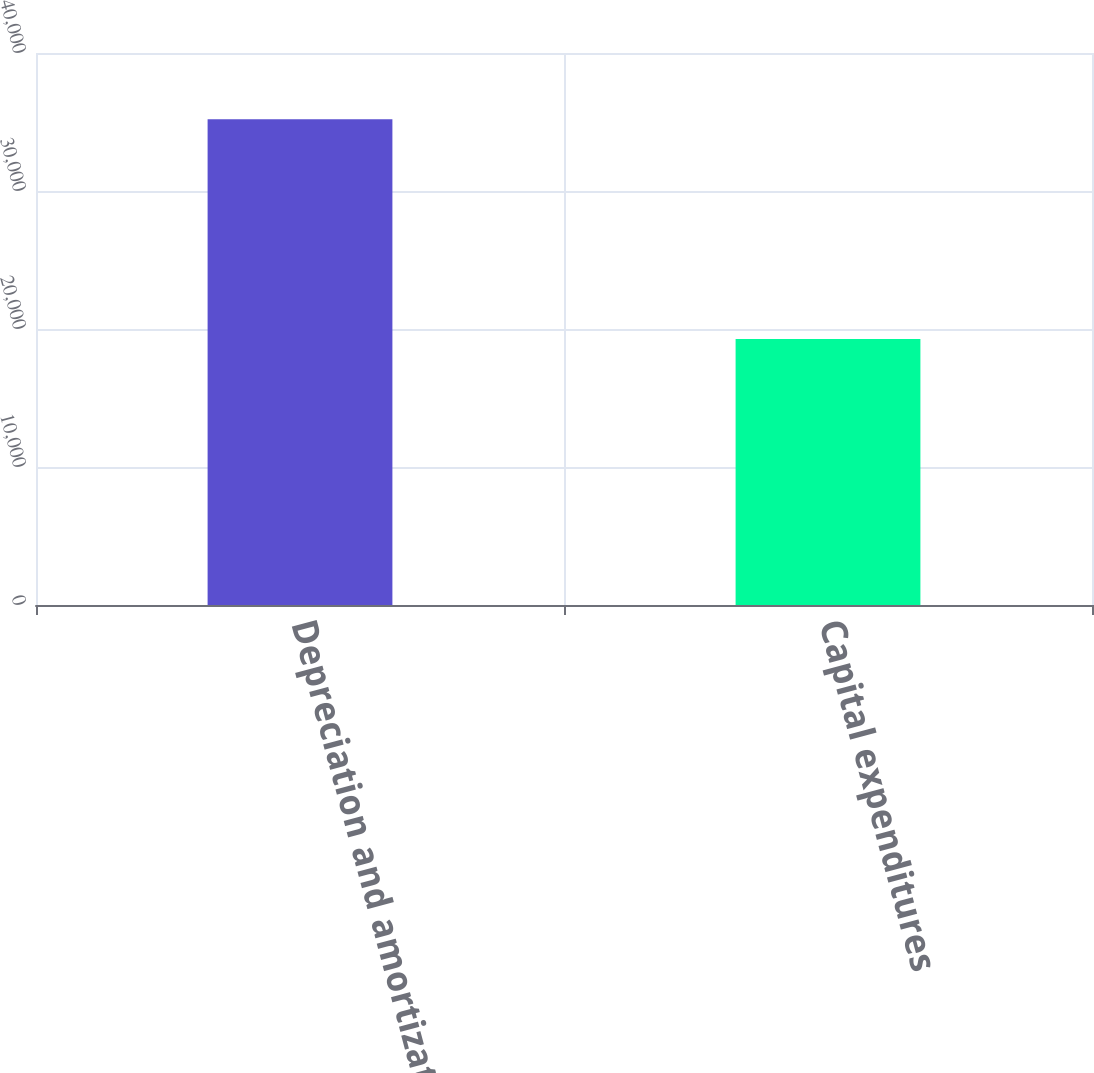<chart> <loc_0><loc_0><loc_500><loc_500><bar_chart><fcel>Depreciation and amortization<fcel>Capital expenditures<nl><fcel>35194<fcel>19281<nl></chart> 